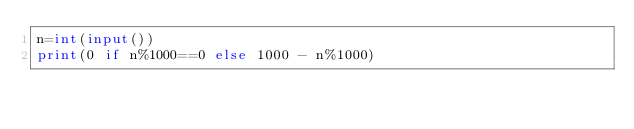Convert code to text. <code><loc_0><loc_0><loc_500><loc_500><_Python_>n=int(input())
print(0 if n%1000==0 else 1000 - n%1000)</code> 